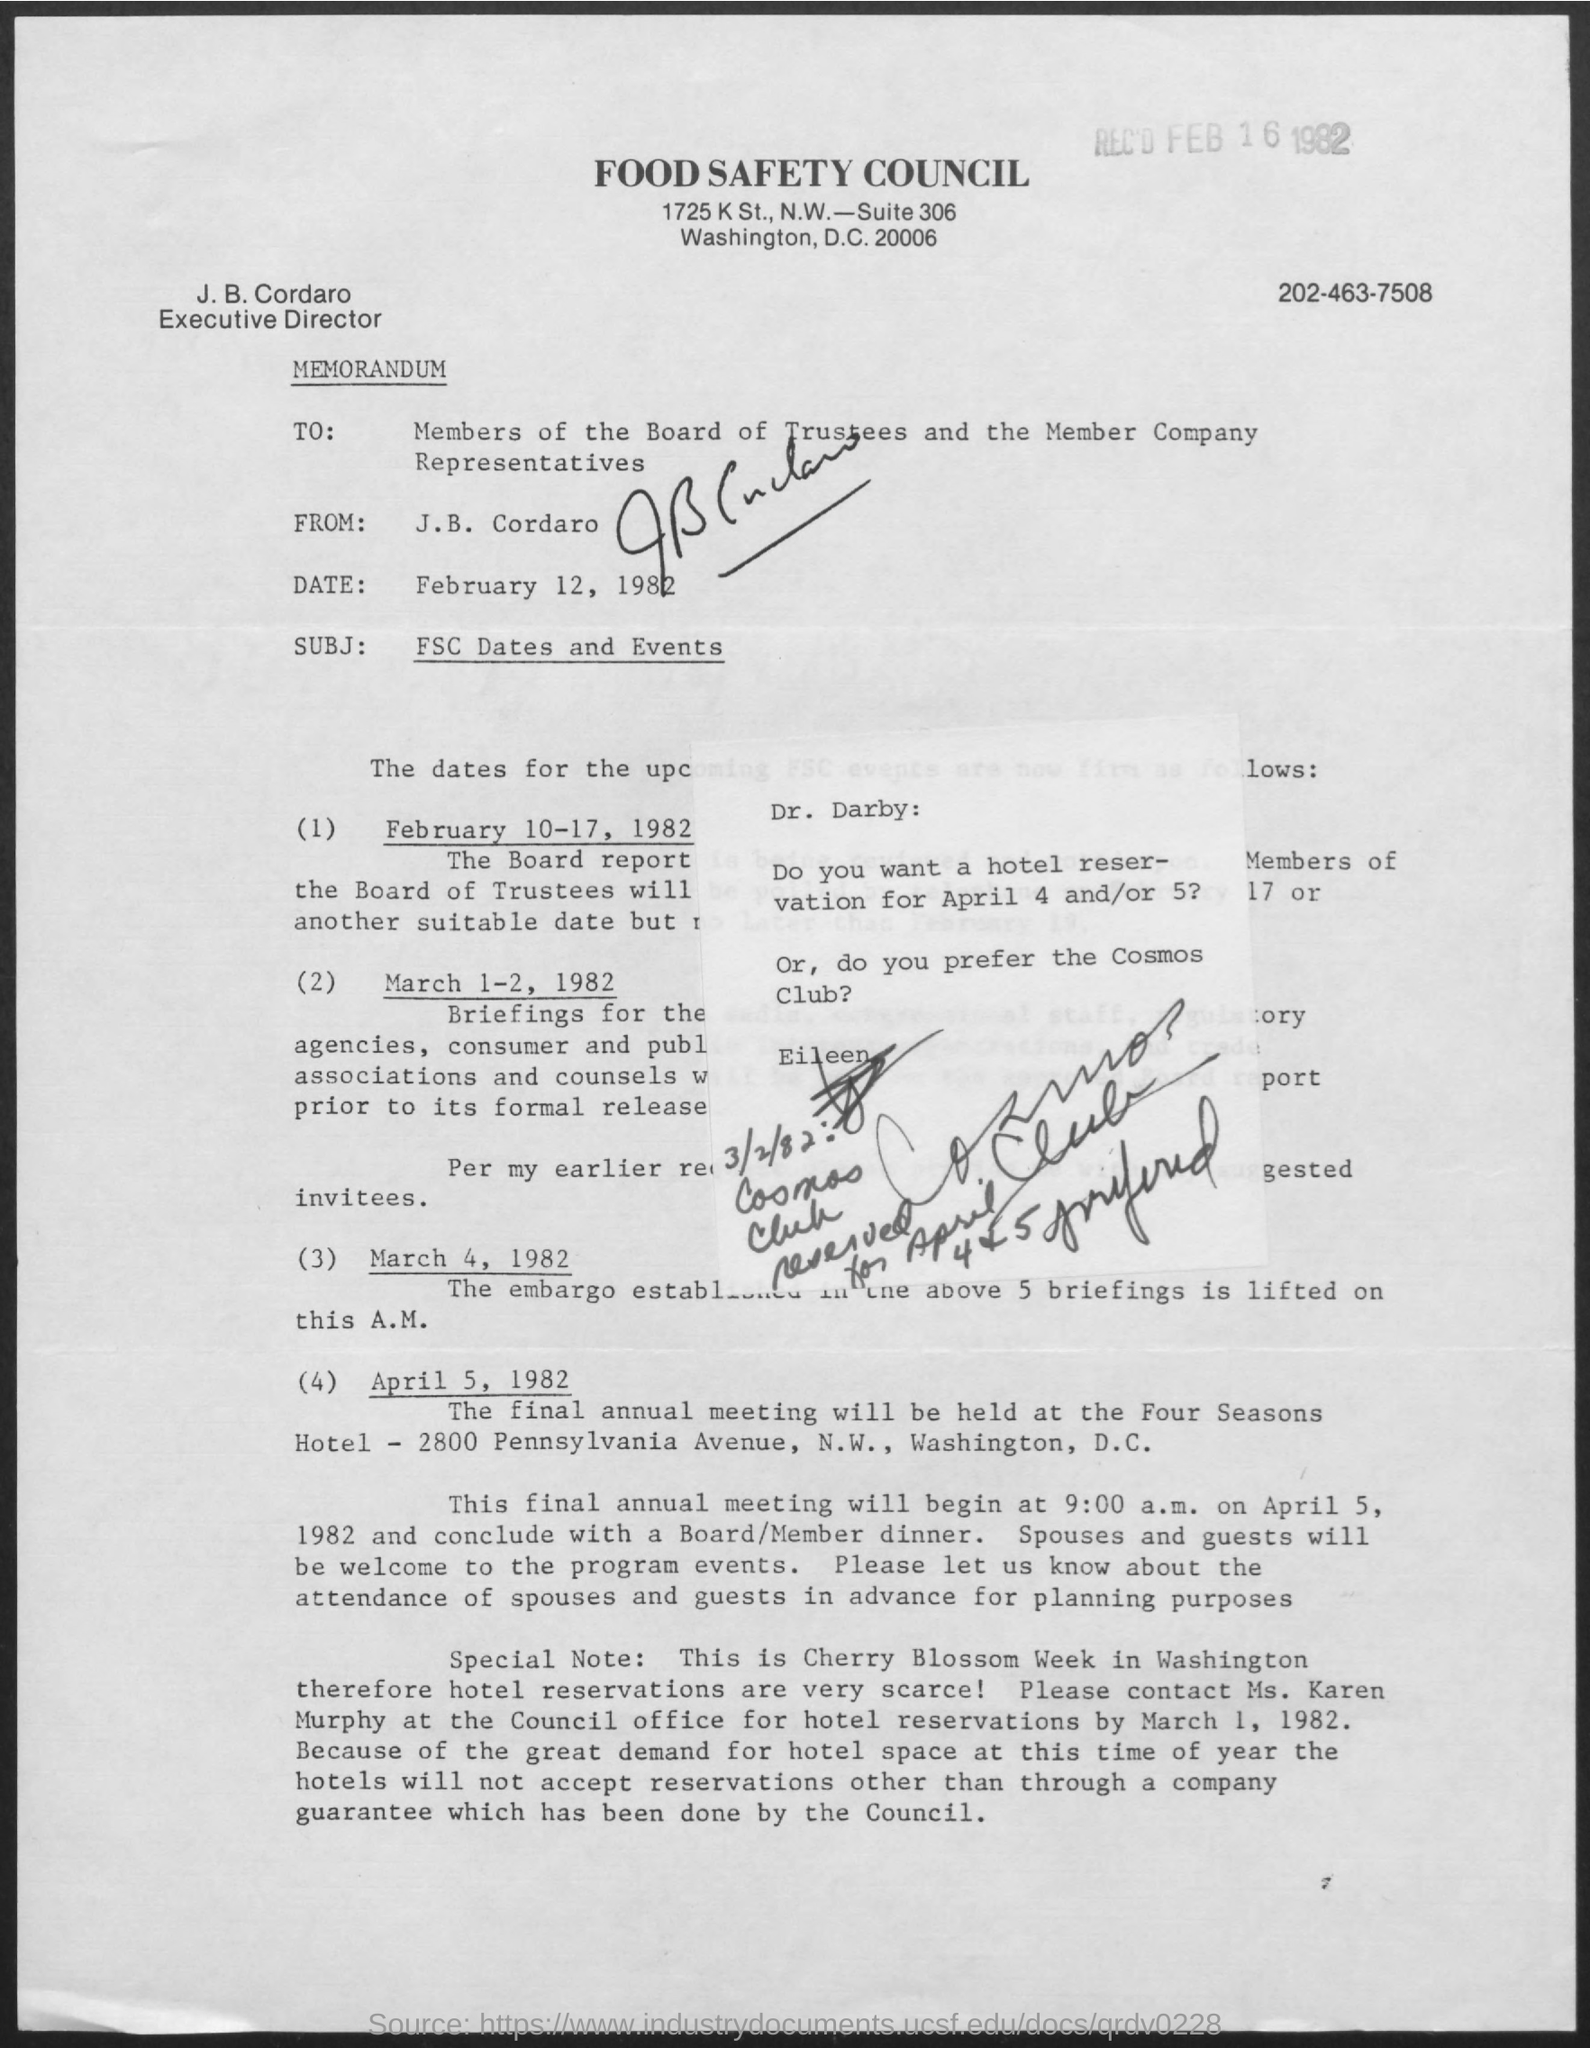Give some essential details in this illustration. The title of the document is "Food Safety Council. The full form of FSC is Food Safety Council. 